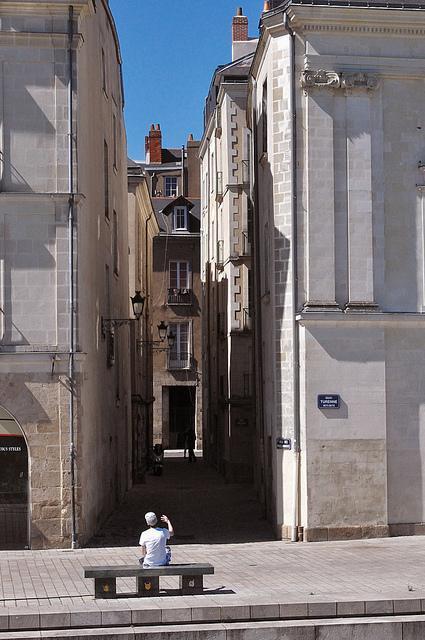How many hot dogs are there?
Give a very brief answer. 0. 